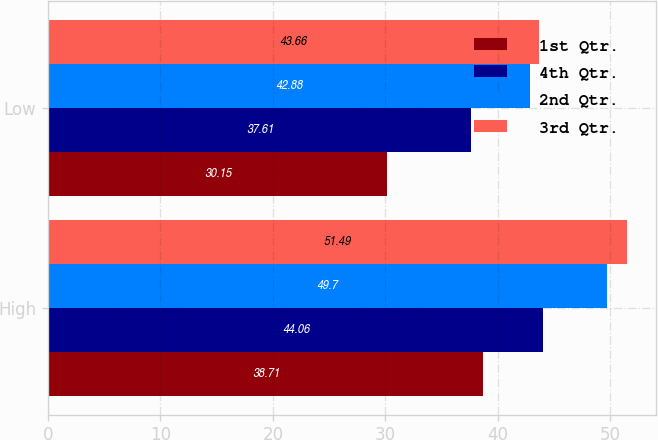Convert chart to OTSL. <chart><loc_0><loc_0><loc_500><loc_500><stacked_bar_chart><ecel><fcel>High<fcel>Low<nl><fcel>1st Qtr.<fcel>38.71<fcel>30.15<nl><fcel>4th Qtr.<fcel>44.06<fcel>37.61<nl><fcel>2nd Qtr.<fcel>49.7<fcel>42.88<nl><fcel>3rd Qtr.<fcel>51.49<fcel>43.66<nl></chart> 